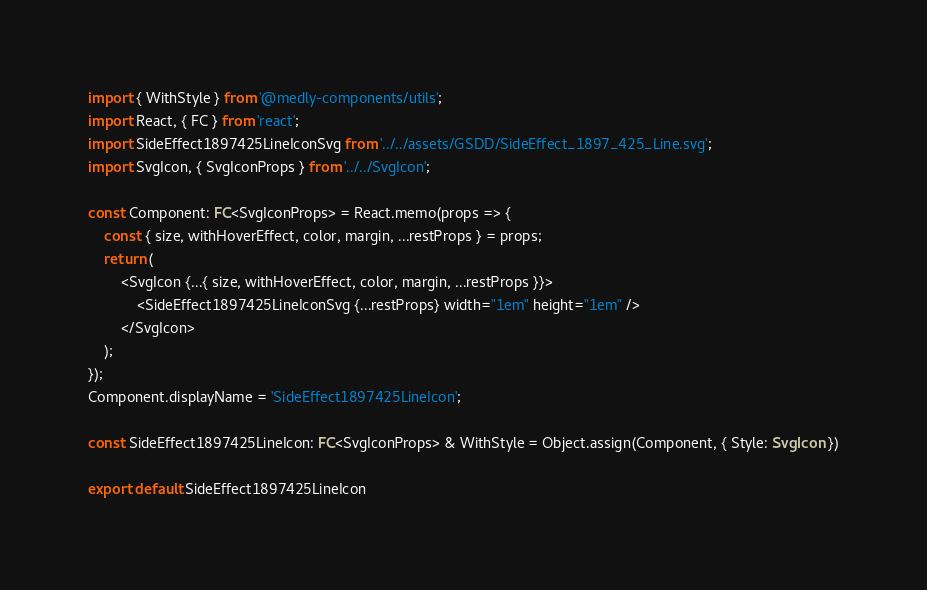<code> <loc_0><loc_0><loc_500><loc_500><_TypeScript_>import { WithStyle } from '@medly-components/utils';
import React, { FC } from 'react';
import SideEffect1897425LineIconSvg from '../../assets/GSDD/SideEffect_1897_425_Line.svg';
import SvgIcon, { SvgIconProps } from '../../SvgIcon';

const Component: FC<SvgIconProps> = React.memo(props => {
    const { size, withHoverEffect, color, margin, ...restProps } = props;
    return (
        <SvgIcon {...{ size, withHoverEffect, color, margin, ...restProps }}>
            <SideEffect1897425LineIconSvg {...restProps} width="1em" height="1em" />
        </SvgIcon>
    );
});
Component.displayName = 'SideEffect1897425LineIcon';

const SideEffect1897425LineIcon: FC<SvgIconProps> & WithStyle = Object.assign(Component, { Style: SvgIcon })

export default SideEffect1897425LineIcon
</code> 